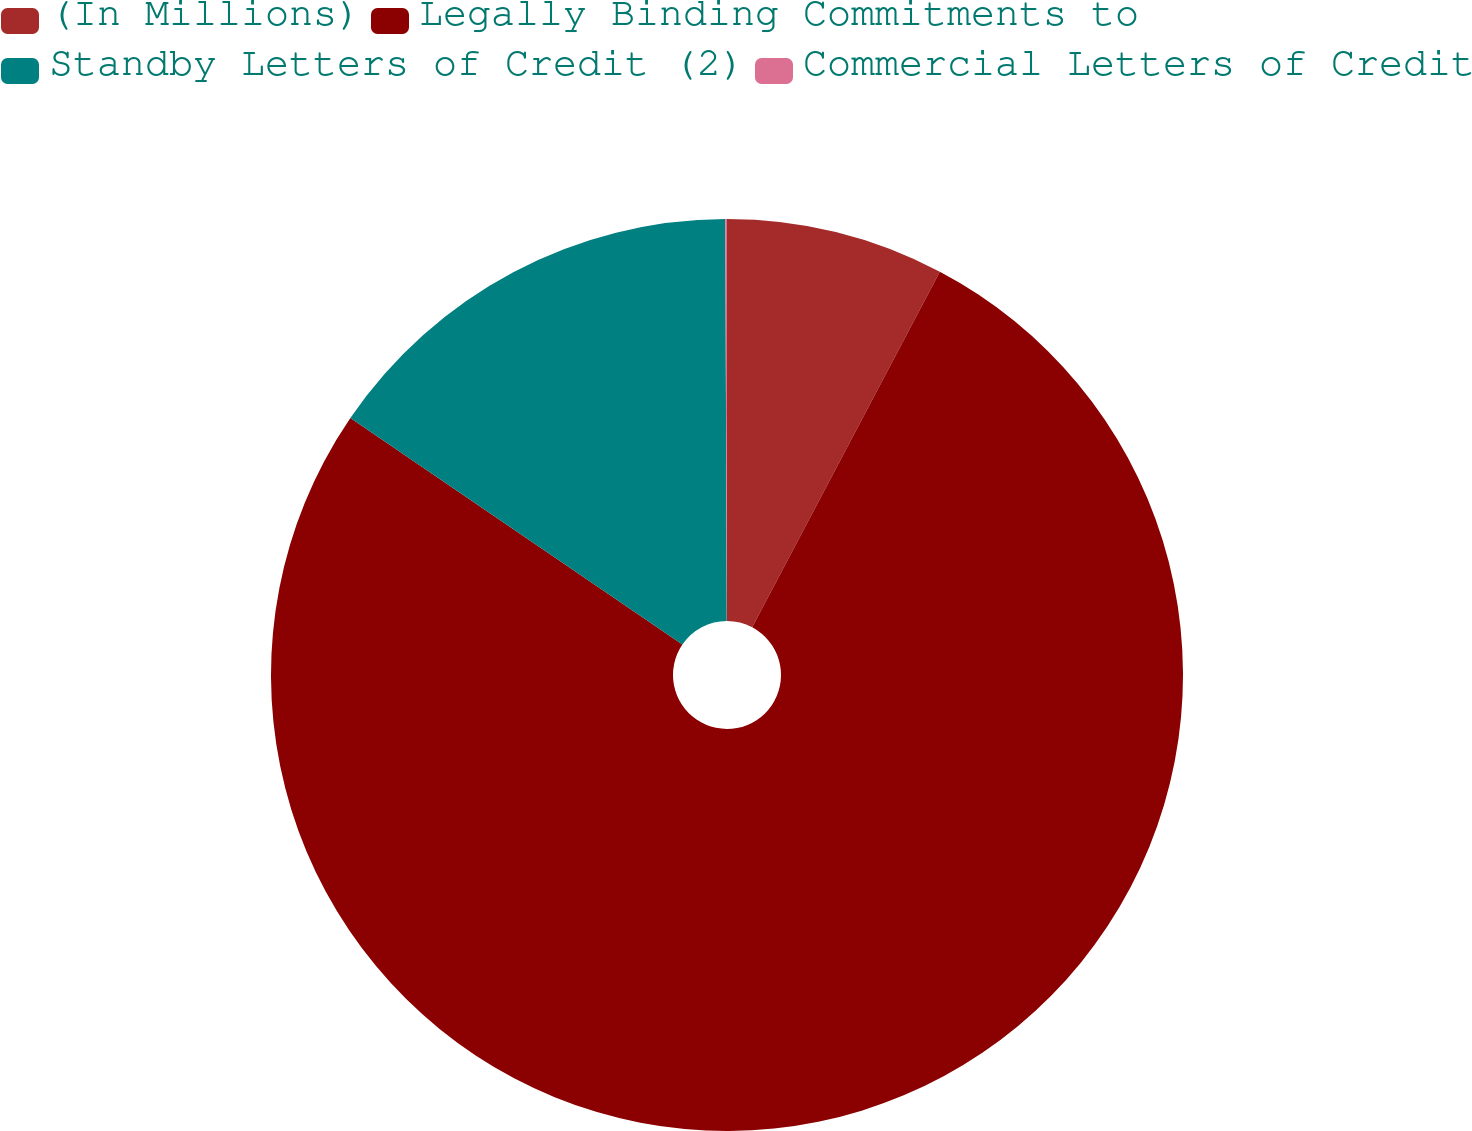Convert chart. <chart><loc_0><loc_0><loc_500><loc_500><pie_chart><fcel>(In Millions)<fcel>Legally Binding Commitments to<fcel>Standby Letters of Credit (2)<fcel>Commercial Letters of Credit<nl><fcel>7.73%<fcel>76.81%<fcel>15.41%<fcel>0.06%<nl></chart> 